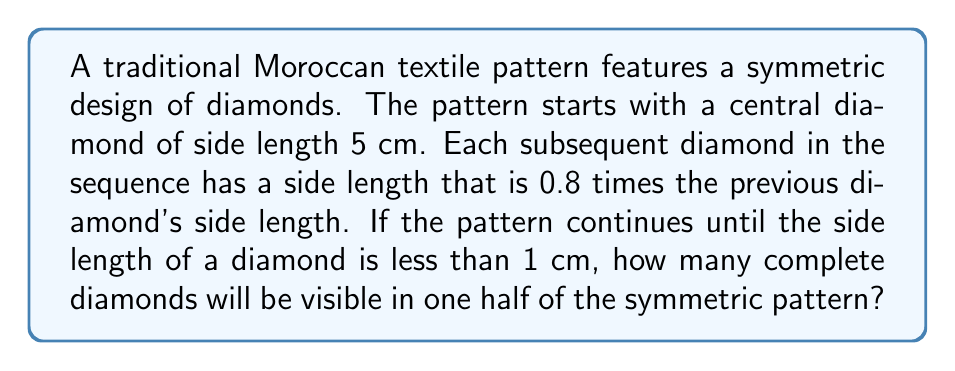Teach me how to tackle this problem. To solve this problem, we need to use the concept of geometric sequences and inequalities. Let's break it down step by step:

1) We start with a geometric sequence where:
   $a_1 = 5$ (the first term, representing the side length of the central diamond in cm)
   $r = 0.8$ (the common ratio)

2) We need to find the largest value of $n$ such that $a_n \geq 1$, where $a_n$ represents the side length of the $n$th diamond.

3) In a geometric sequence, the $n$th term is given by:
   $a_n = a_1 \cdot r^{n-1}$

4) We can set up the inequality:
   $a_1 \cdot r^{n-1} \geq 1$

5) Substituting the values:
   $5 \cdot (0.8)^{n-1} \geq 1$

6) Solving for $n$:
   $(0.8)^{n-1} \geq \frac{1}{5}$
   $n-1 \geq \log_{0.8}(\frac{1}{5})$
   $n \geq \log_{0.8}(\frac{1}{5}) + 1$

7) Using a calculator or logarithm properties:
   $n \geq \frac{\log(0.2)}{\log(0.8)} + 1 \approx 7.0458$

8) Since $n$ must be an integer and we want the largest value that satisfies the inequality, we round down to 7.

9) This means there will be 7 diamonds in the sequence from the center outwards, including the central diamond.

10) However, the question asks for the number of diamonds in one half of the symmetric pattern. The central diamond is counted only once, so we need to subtract 1 from our total and divide by 2:
    $\frac{7-1}{2} = 3$

Therefore, there will be 3 complete diamonds visible in one half of the symmetric pattern.
Answer: 3 diamonds 